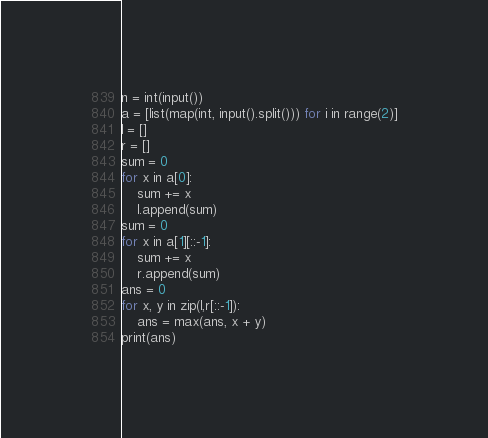Convert code to text. <code><loc_0><loc_0><loc_500><loc_500><_Python_>n = int(input())
a = [list(map(int, input().split())) for i in range(2)]
l = []
r = []
sum = 0
for x in a[0]:
    sum += x
    l.append(sum)
sum = 0
for x in a[1][::-1]:
    sum += x
    r.append(sum)
ans = 0
for x, y in zip(l,r[::-1]):
    ans = max(ans, x + y)
print(ans)</code> 